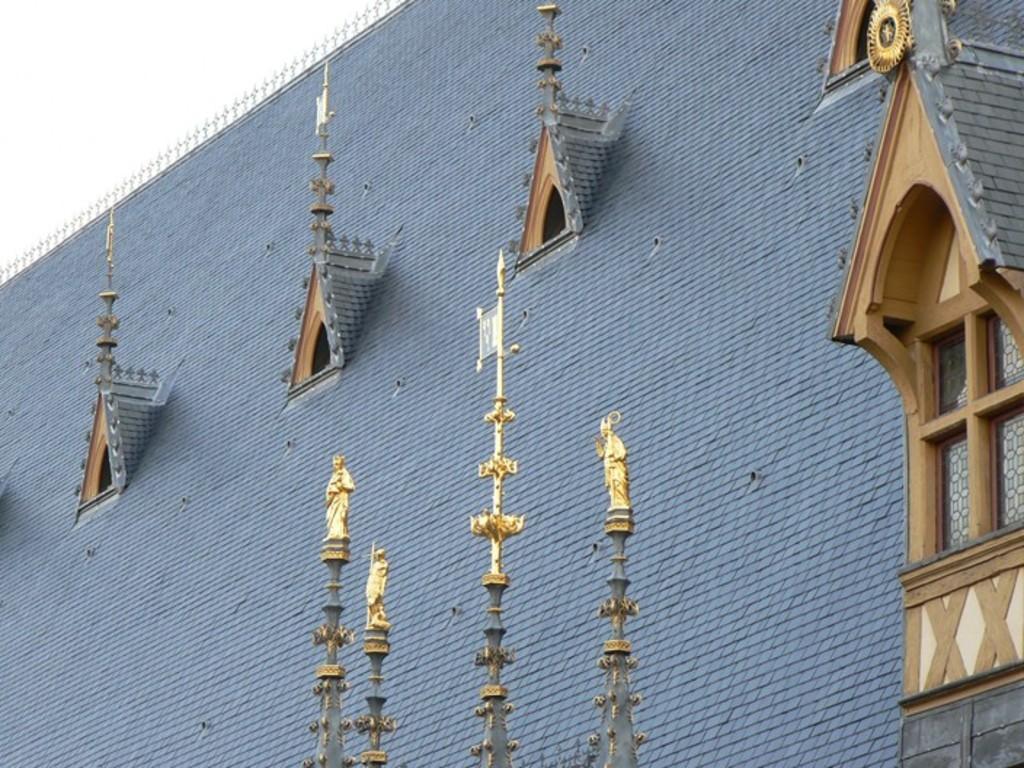Can you describe this image briefly? In this image there is a wall of a building. To the wall there are ventilators and glass windows. There are small sculptures on the building. In the top left there is the sky. 